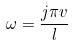<formula> <loc_0><loc_0><loc_500><loc_500>\omega = \frac { j \pi v } { l }</formula> 